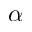<formula> <loc_0><loc_0><loc_500><loc_500>\alpha</formula> 